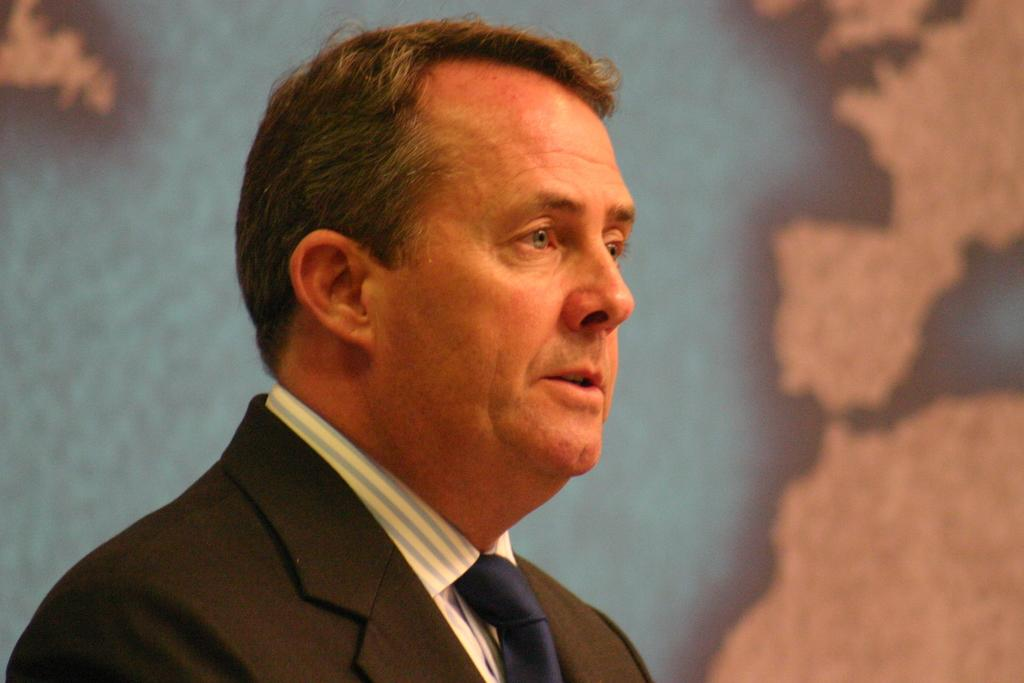What is the main subject of the image? There is a person in the image. Can you describe the person's attire? The person is wearing a suit. What can be observed about the background of the image? The background of the image is blurred. What type of coil is visible on the ground in the image? There is no coil visible on the ground in the image. What appliance is being used by the person in the image? The image does not show any appliances being used by the person. 